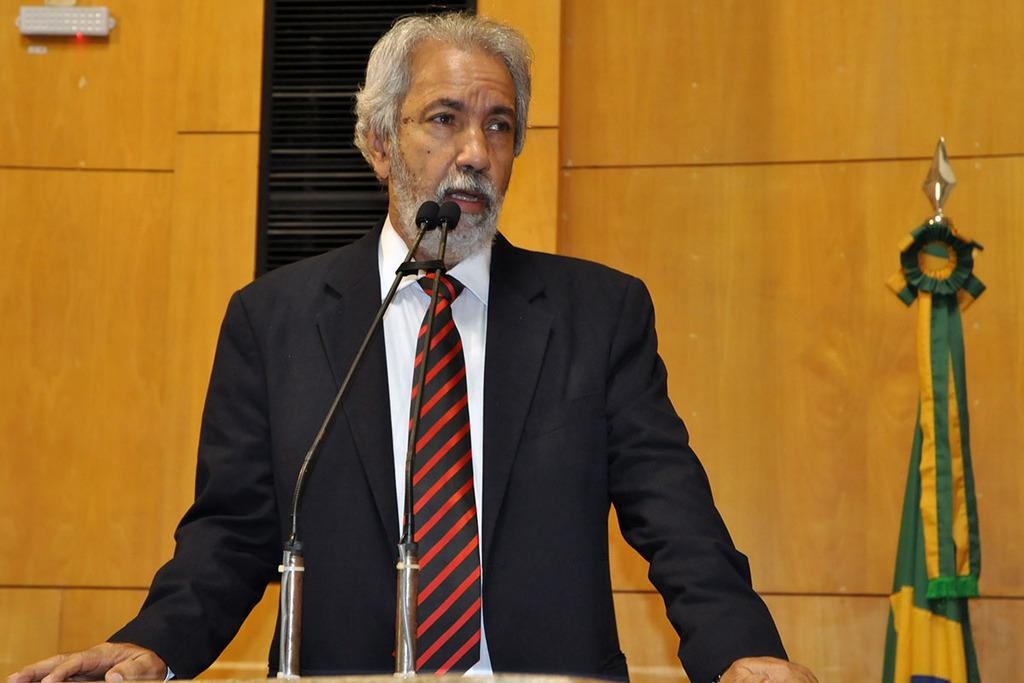Who is in the image? There is a man in the image. What is the man wearing? The man is wearing a black suit. What is the man doing in the image? The man is standing and talking into a microphone. What can be seen in the background of the image? There is a brown-colored wall in the background of the image. What is located to the right of the image? There are flags to the right of the image. What type of thread is being used to create the circle in the image? There is no circle present in the image, so there is no thread being used. 